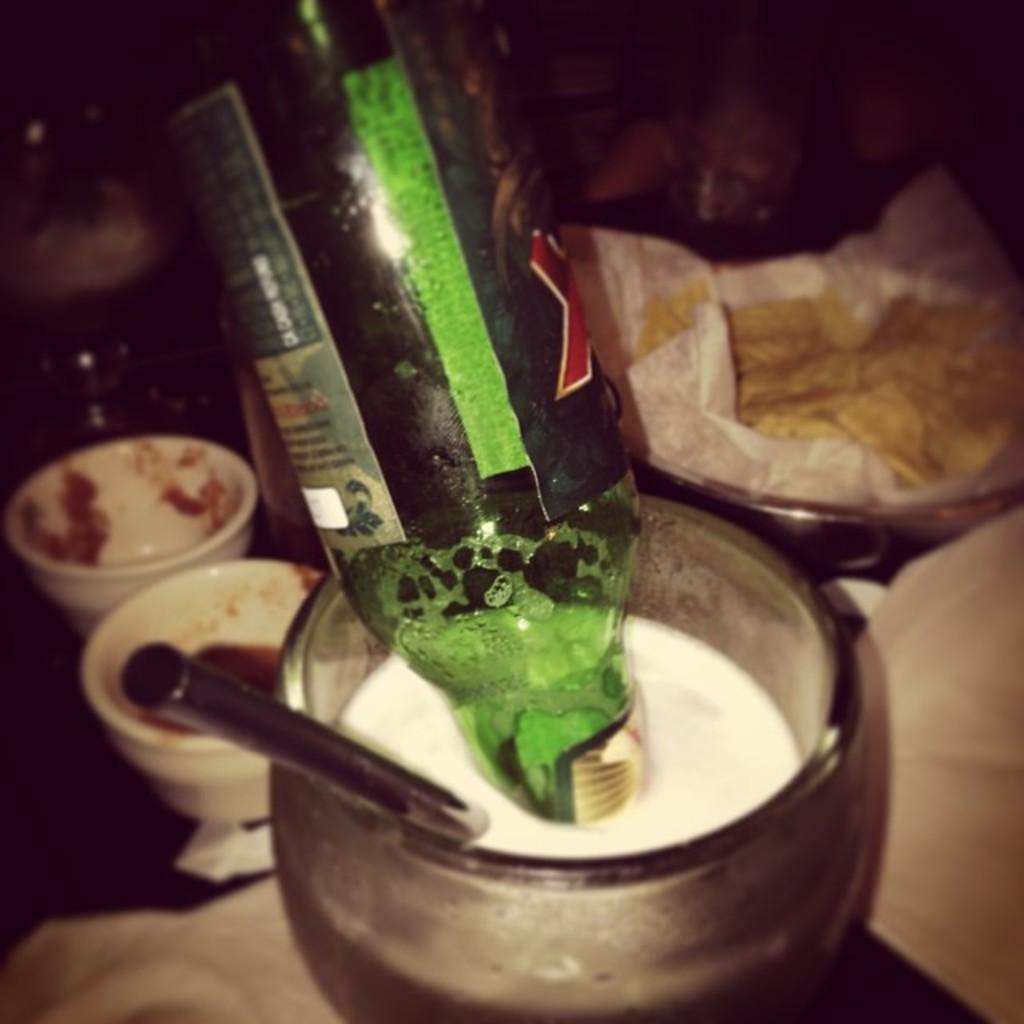Can you describe this image briefly? There is a straw and bottle in the glass. The two cups and tissue in the background. 